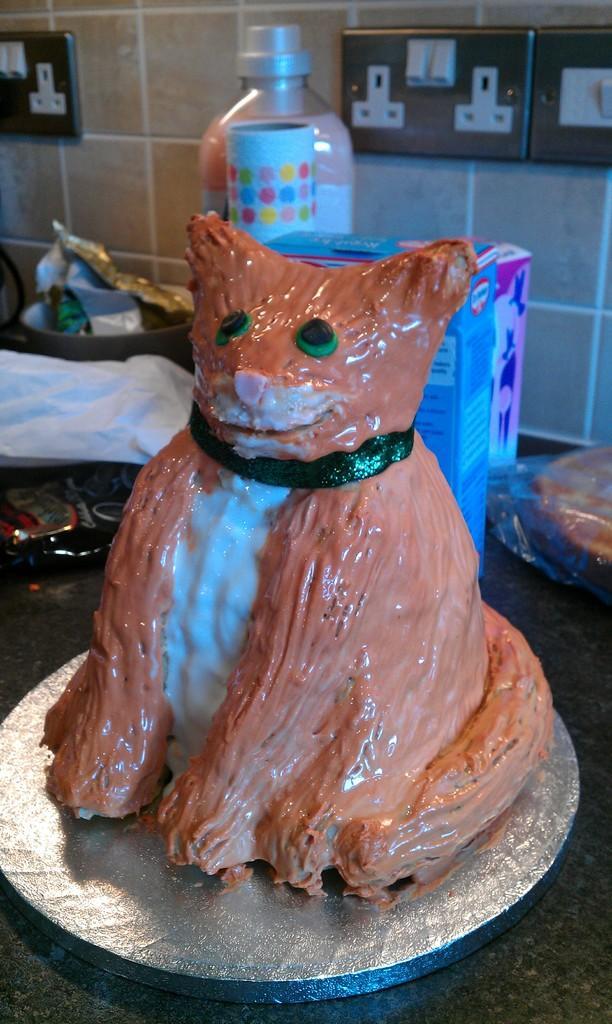In one or two sentences, can you explain what this image depicts? This picture is mainly highlighted with a coke, bottle, boxes, food in a box, packets on the kitchen platform. On the background we can see sockets and wall with tiles. 